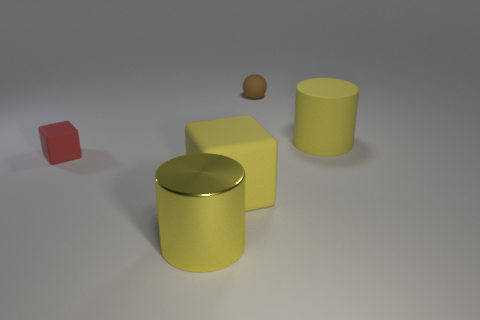What number of objects are small things that are in front of the brown matte ball or big yellow matte things in front of the rubber cylinder?
Ensure brevity in your answer.  2. Is the size of the cylinder that is behind the yellow metallic object the same as the red matte cube in front of the sphere?
Provide a succinct answer. No. Is there a red matte thing that is to the right of the large yellow rubber object right of the brown object?
Give a very brief answer. No. There is a yellow metallic cylinder; what number of yellow objects are behind it?
Provide a short and direct response. 2. What number of other things are there of the same color as the small rubber sphere?
Make the answer very short. 0. Is the number of small brown balls in front of the brown rubber sphere less than the number of yellow matte objects behind the big matte cube?
Make the answer very short. Yes. What number of objects are either small rubber things left of the large cube or brown objects?
Your answer should be very brief. 2. Do the yellow cube and the cylinder behind the metal object have the same size?
Your response must be concise. Yes. What is the size of the yellow object that is the same shape as the red object?
Your answer should be very brief. Large. There is a yellow object that is behind the object that is to the left of the big yellow shiny cylinder; what number of yellow things are behind it?
Ensure brevity in your answer.  0. 